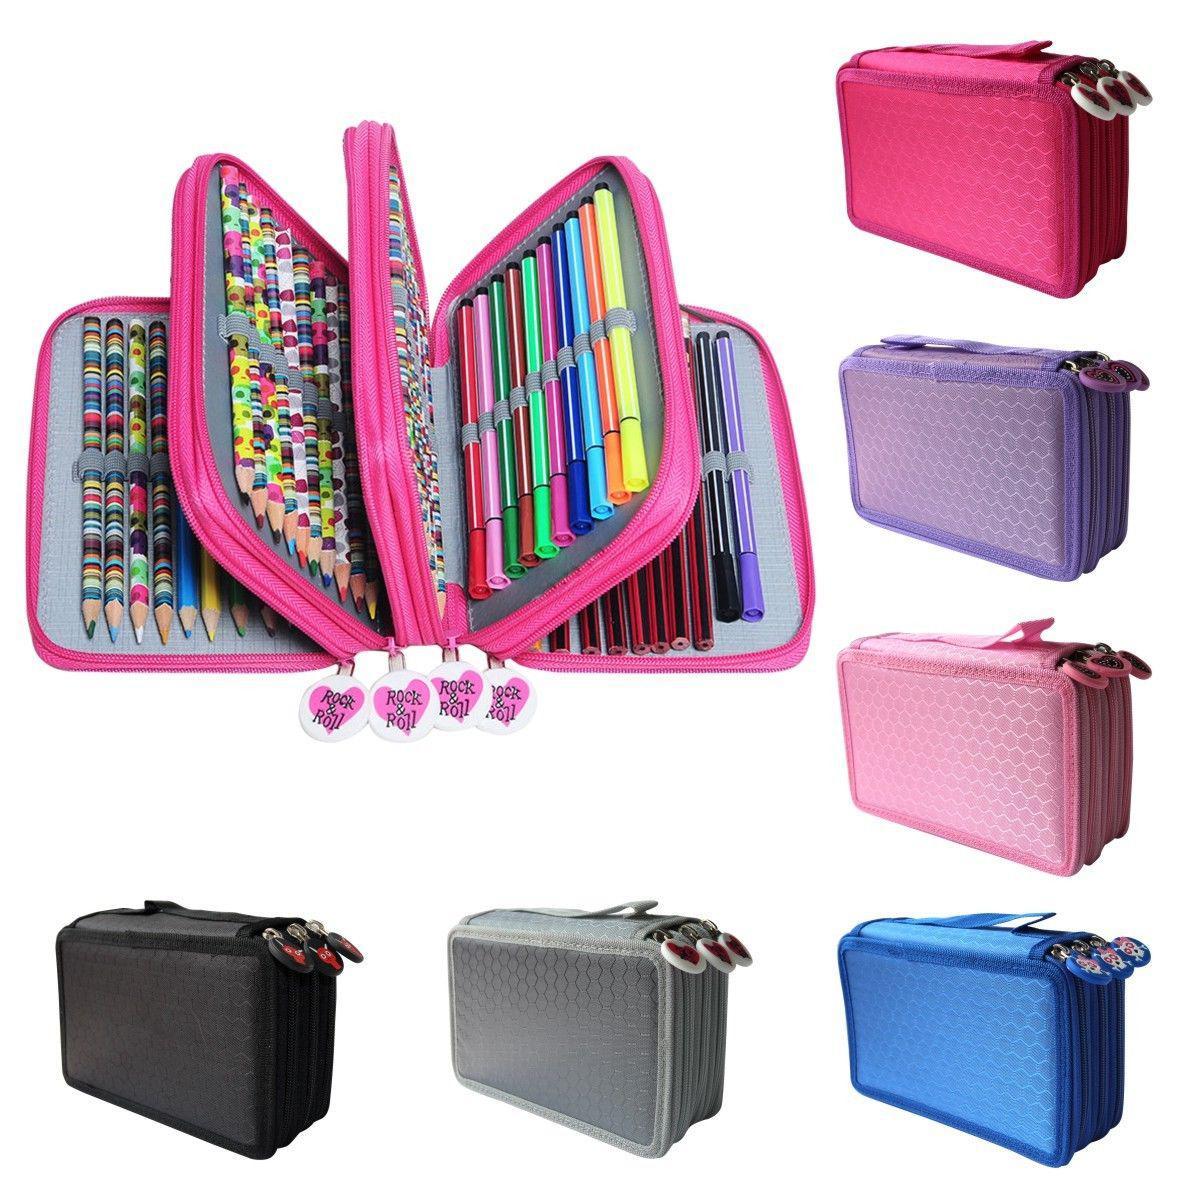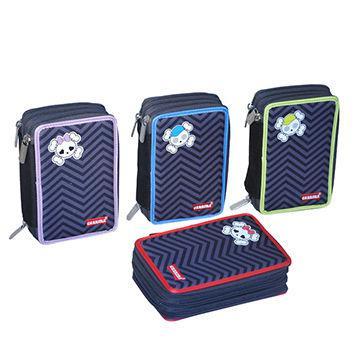The first image is the image on the left, the second image is the image on the right. For the images displayed, is the sentence "An image features a bright pink case that is fanned open to reveal multiple sections holding a variety of writing implements." factually correct? Answer yes or no. Yes. The first image is the image on the left, the second image is the image on the right. Assess this claim about the two images: "There are exactly three pencil cases.". Correct or not? Answer yes or no. No. 